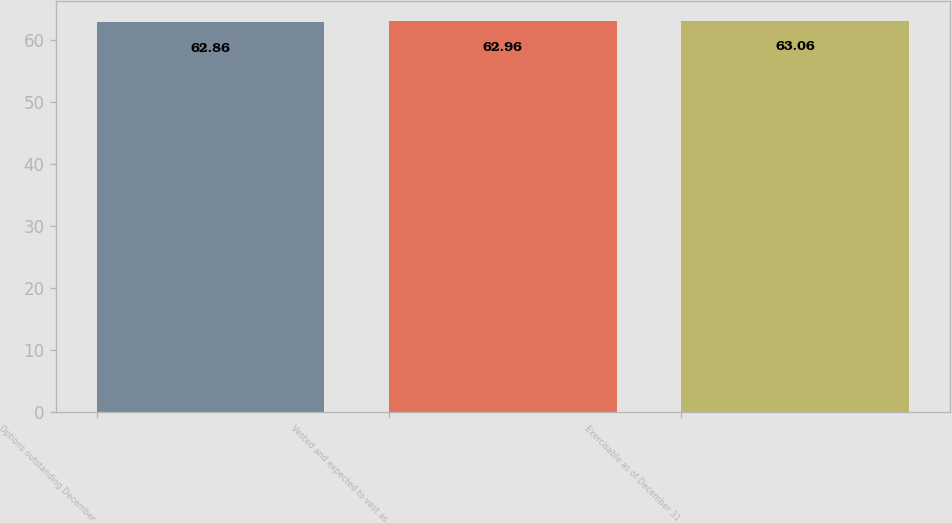Convert chart to OTSL. <chart><loc_0><loc_0><loc_500><loc_500><bar_chart><fcel>Options outstanding December<fcel>Vested and expected to vest as<fcel>Exercisable as of December 31<nl><fcel>62.86<fcel>62.96<fcel>63.06<nl></chart> 